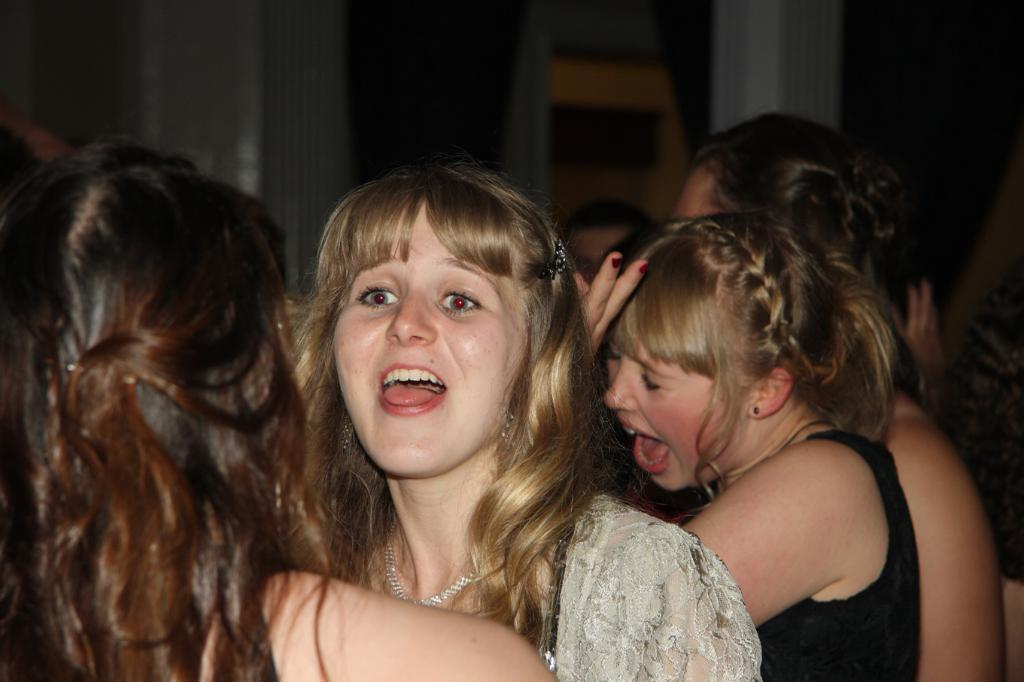How many people are in the image? There are many girls in the image. What are the girls doing in the image? The girls are shouting. What type of event might be taking place in the image? It appears to be a party. What can be seen in the background of the image? There is a wall in the background of the image. What type of shade is being used to cover the stone in the image? There is no shade or stone present in the image; it features many girls shouting at a party. 